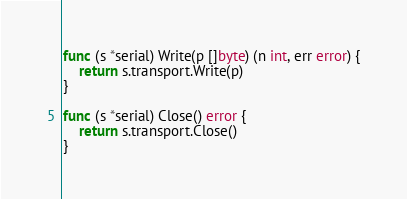<code> <loc_0><loc_0><loc_500><loc_500><_Go_>
func (s *serial) Write(p []byte) (n int, err error) {
	return s.transport.Write(p)
}

func (s *serial) Close() error {
	return s.transport.Close()
}
</code> 